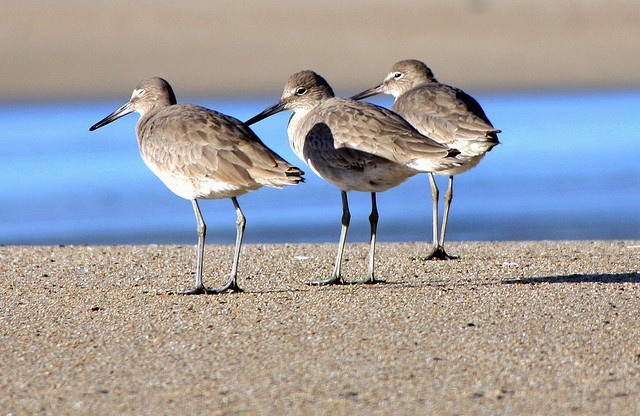Describe the objects in this image and their specific colors. I can see bird in darkgray, black, gray, and ivory tones, bird in darkgray, white, and tan tones, and bird in darkgray, lightgray, tan, and gray tones in this image. 